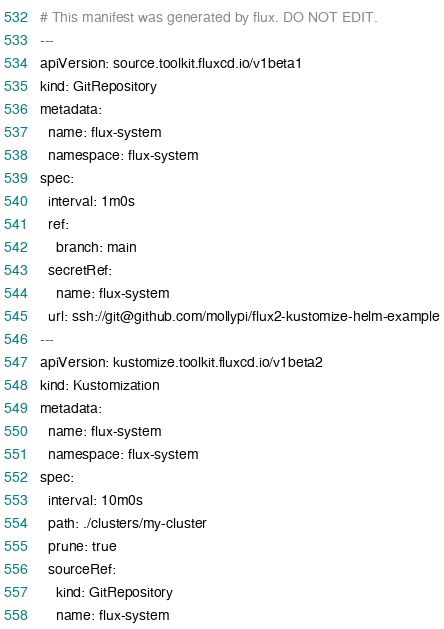<code> <loc_0><loc_0><loc_500><loc_500><_YAML_># This manifest was generated by flux. DO NOT EDIT.
---
apiVersion: source.toolkit.fluxcd.io/v1beta1
kind: GitRepository
metadata:
  name: flux-system
  namespace: flux-system
spec:
  interval: 1m0s
  ref:
    branch: main
  secretRef:
    name: flux-system
  url: ssh://git@github.com/mollypi/flux2-kustomize-helm-example
---
apiVersion: kustomize.toolkit.fluxcd.io/v1beta2
kind: Kustomization
metadata:
  name: flux-system
  namespace: flux-system
spec:
  interval: 10m0s
  path: ./clusters/my-cluster
  prune: true
  sourceRef:
    kind: GitRepository
    name: flux-system
</code> 